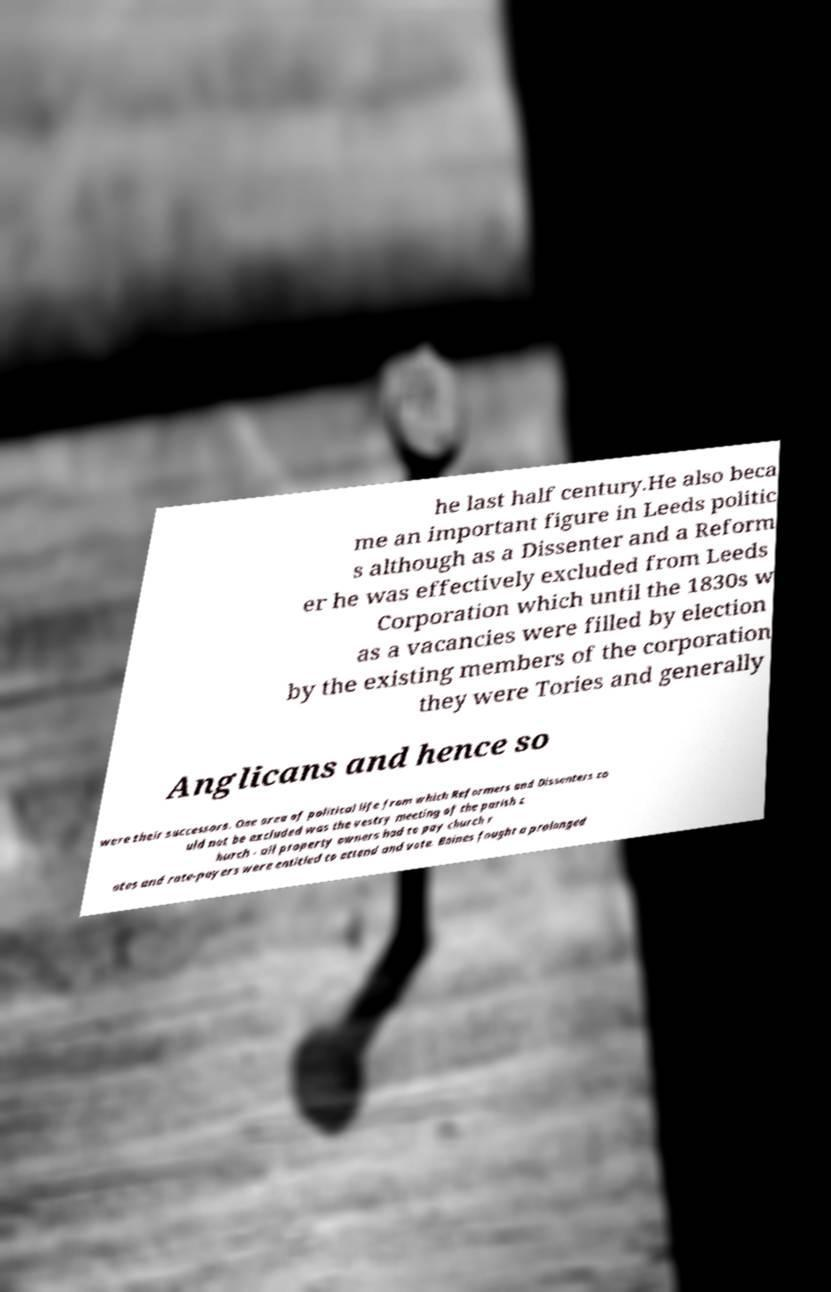I need the written content from this picture converted into text. Can you do that? he last half century.He also beca me an important figure in Leeds politic s although as a Dissenter and a Reform er he was effectively excluded from Leeds Corporation which until the 1830s w as a vacancies were filled by election by the existing members of the corporation they were Tories and generally Anglicans and hence so were their successors. One area of political life from which Reformers and Dissenters co uld not be excluded was the vestry meeting of the parish c hurch - all property owners had to pay church r ates and rate-payers were entitled to attend and vote. Baines fought a prolonged 